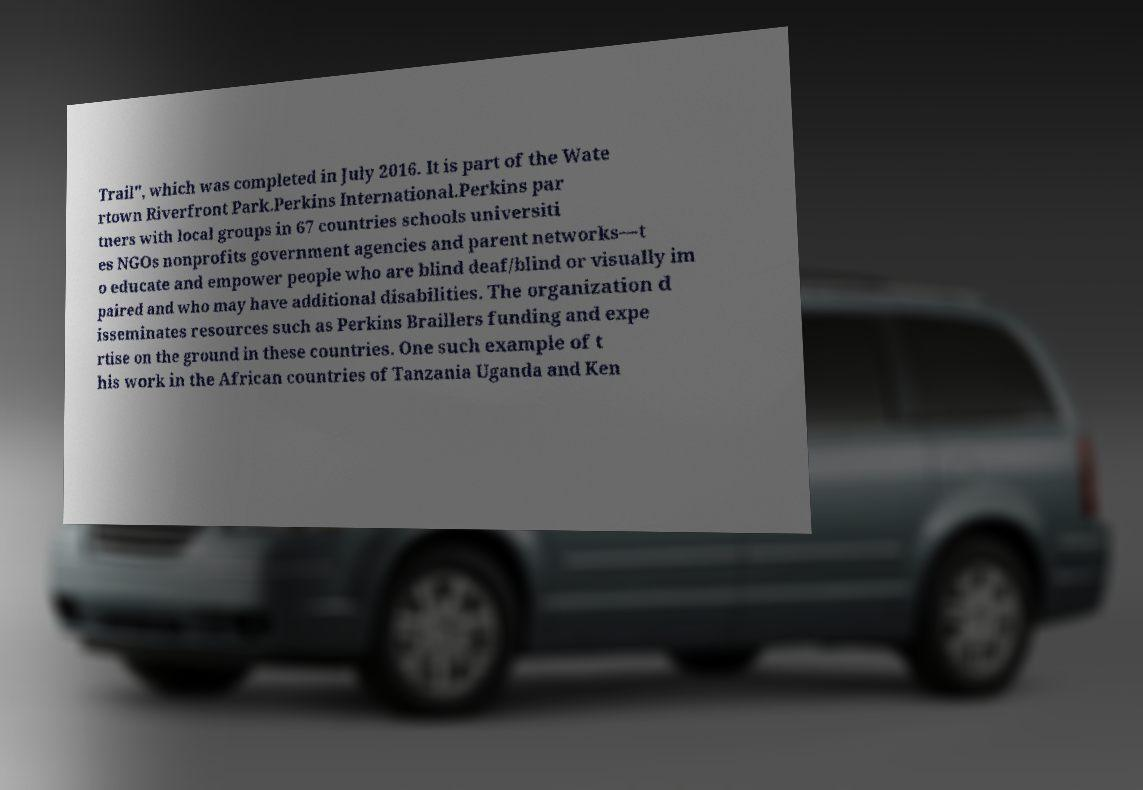Could you assist in decoding the text presented in this image and type it out clearly? Trail", which was completed in July 2016. It is part of the Wate rtown Riverfront Park.Perkins International.Perkins par tners with local groups in 67 countries schools universiti es NGOs nonprofits government agencies and parent networks—t o educate and empower people who are blind deaf/blind or visually im paired and who may have additional disabilities. The organization d isseminates resources such as Perkins Braillers funding and expe rtise on the ground in these countries. One such example of t his work in the African countries of Tanzania Uganda and Ken 